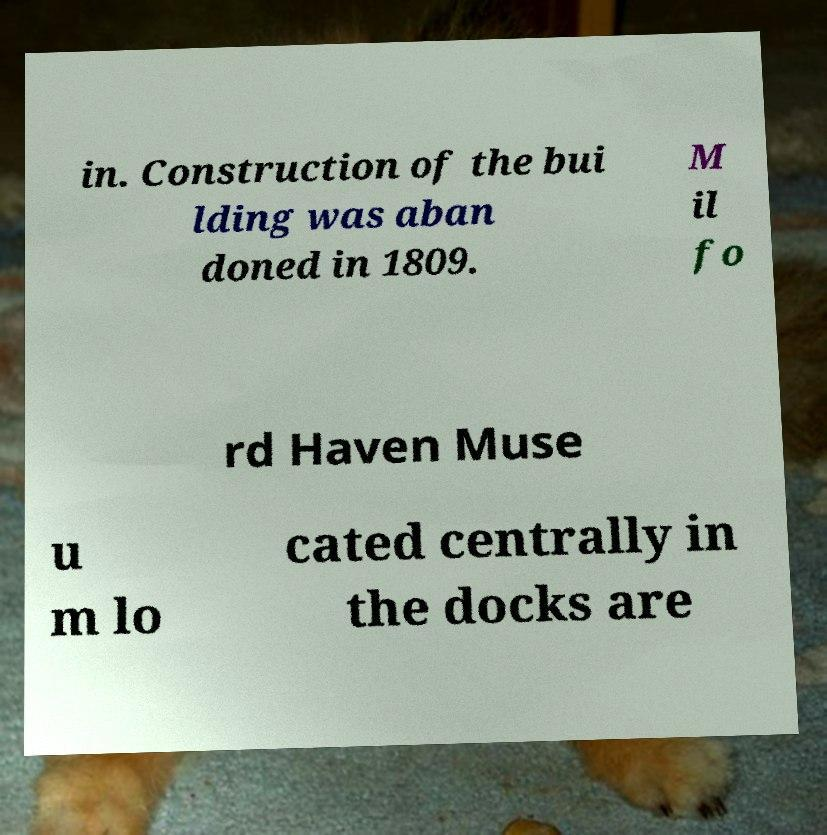Could you extract and type out the text from this image? in. Construction of the bui lding was aban doned in 1809. M il fo rd Haven Muse u m lo cated centrally in the docks are 